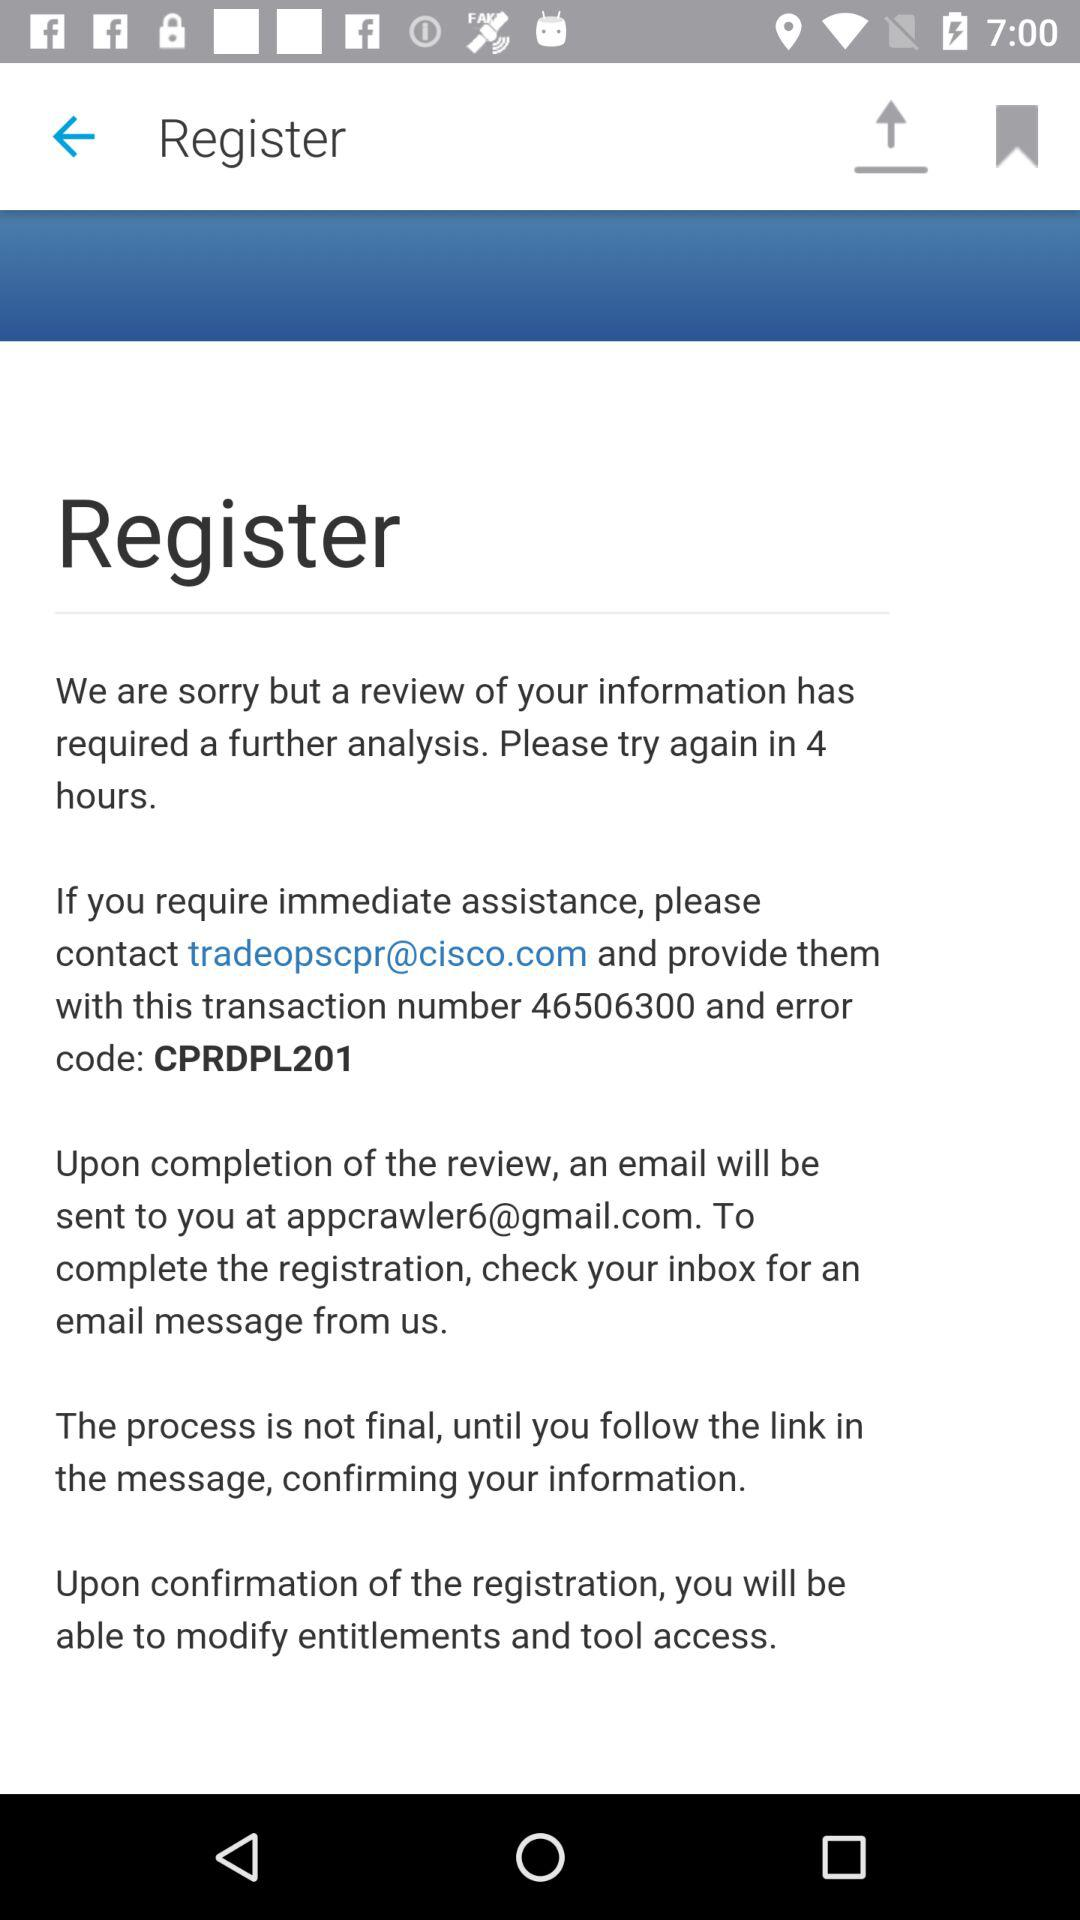What is the email address for assistance? The email address for assistance is tradeopscpr@cisco.com. 